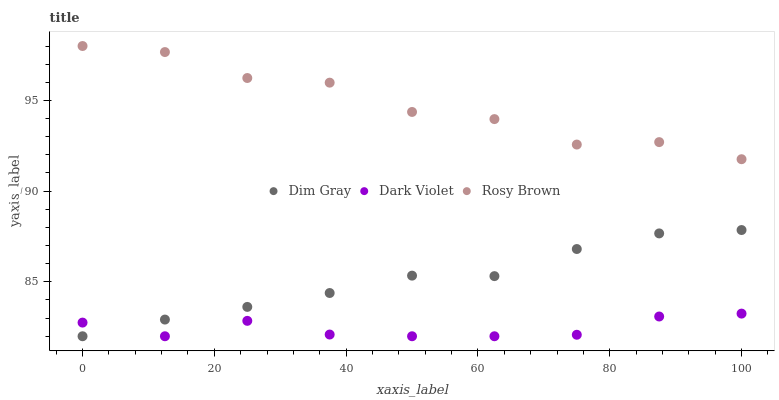Does Dark Violet have the minimum area under the curve?
Answer yes or no. Yes. Does Rosy Brown have the maximum area under the curve?
Answer yes or no. Yes. Does Dim Gray have the minimum area under the curve?
Answer yes or no. No. Does Dim Gray have the maximum area under the curve?
Answer yes or no. No. Is Dim Gray the smoothest?
Answer yes or no. Yes. Is Rosy Brown the roughest?
Answer yes or no. Yes. Is Dark Violet the smoothest?
Answer yes or no. No. Is Dark Violet the roughest?
Answer yes or no. No. Does Dim Gray have the lowest value?
Answer yes or no. Yes. Does Rosy Brown have the highest value?
Answer yes or no. Yes. Does Dim Gray have the highest value?
Answer yes or no. No. Is Dark Violet less than Rosy Brown?
Answer yes or no. Yes. Is Rosy Brown greater than Dim Gray?
Answer yes or no. Yes. Does Dark Violet intersect Dim Gray?
Answer yes or no. Yes. Is Dark Violet less than Dim Gray?
Answer yes or no. No. Is Dark Violet greater than Dim Gray?
Answer yes or no. No. Does Dark Violet intersect Rosy Brown?
Answer yes or no. No. 